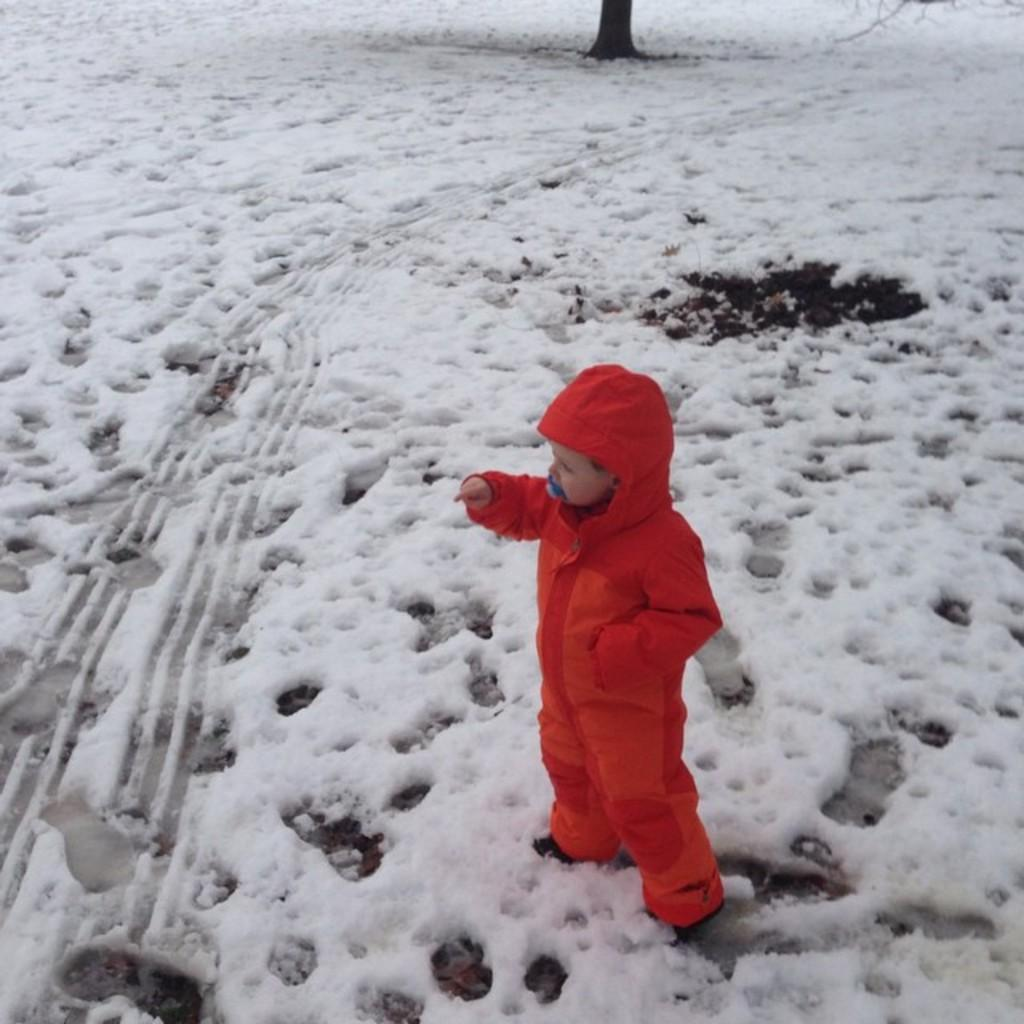What is the main subject of the image? There is a person in the image. What is the condition of the ground in the image? The ground is covered with snow. Can you describe the object on the top side of the image? Unfortunately, there is not enough information provided about the object on the top side of the image. What type of guide is the person holding in the image? There is no guide present in the image; it only shows a person and snow-covered ground. 